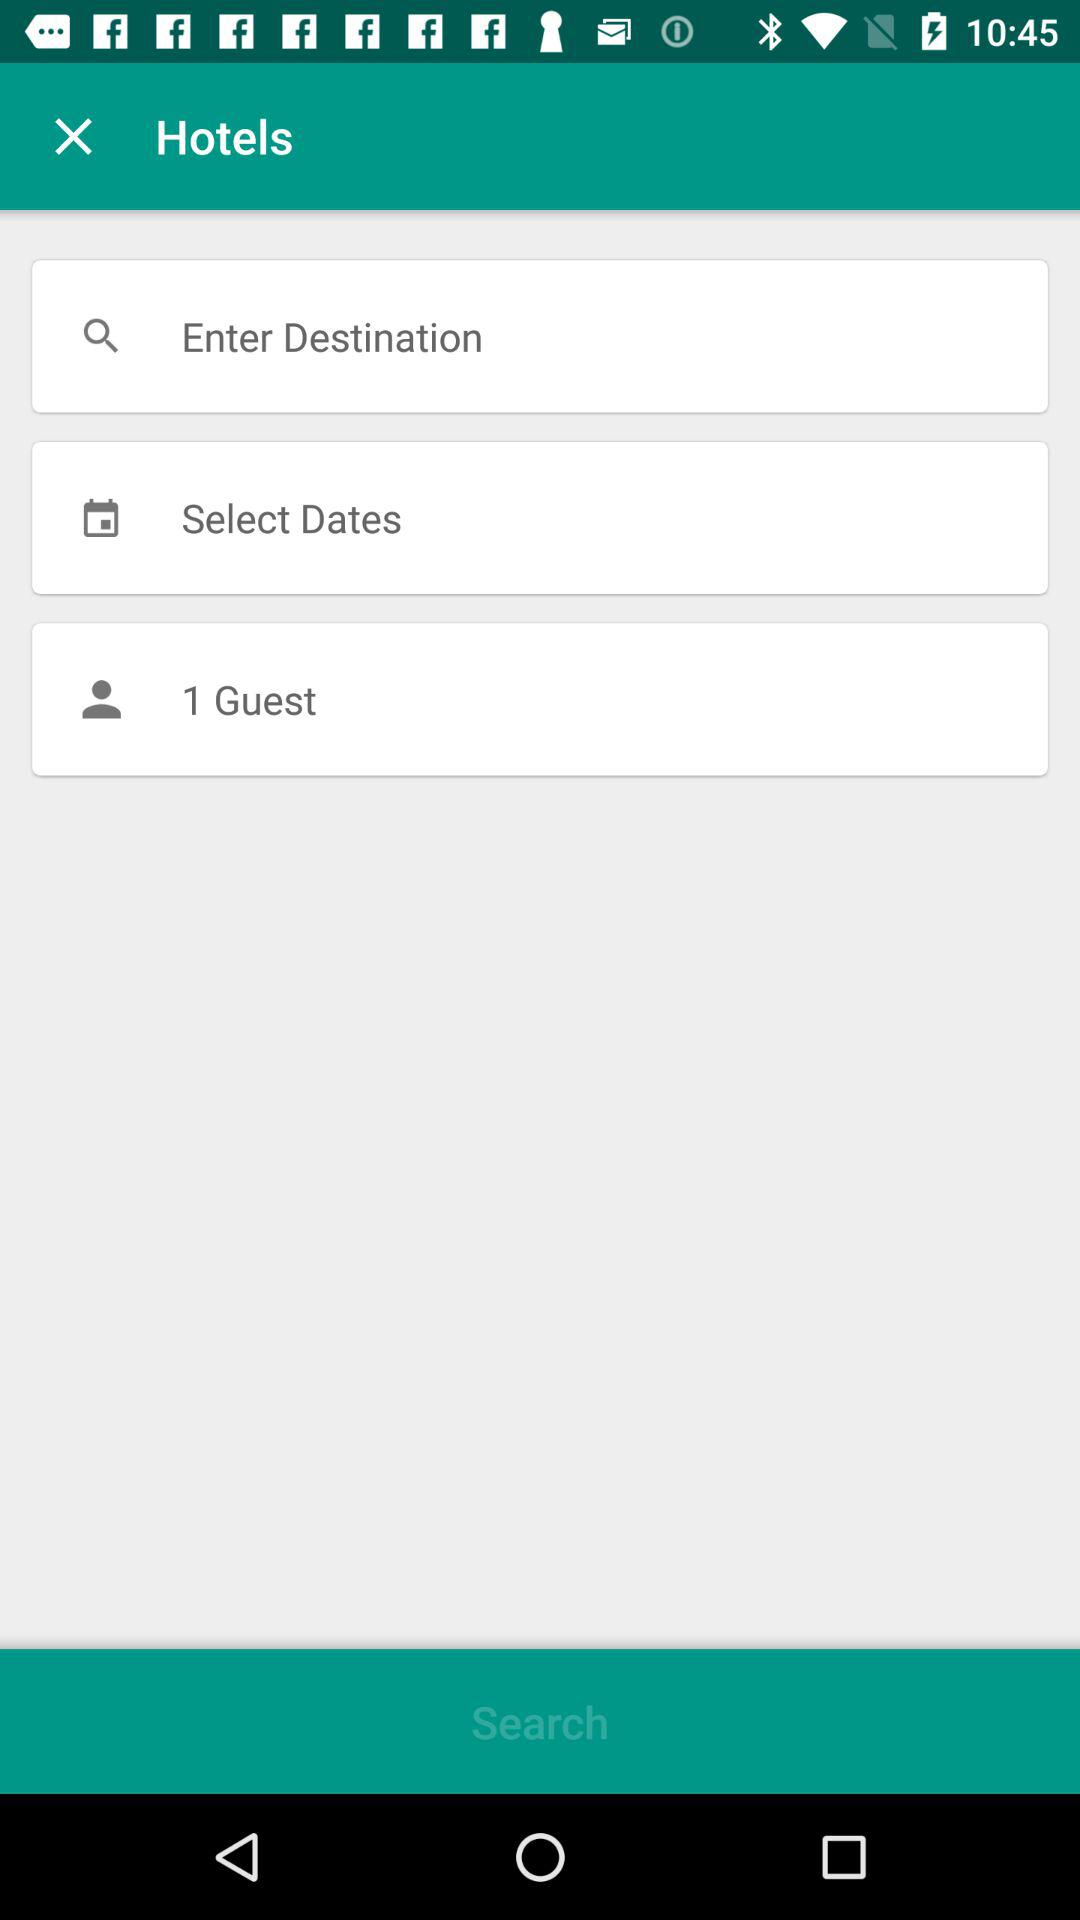Which date is selected for the visit?
When the provided information is insufficient, respond with <no answer>. <no answer> 